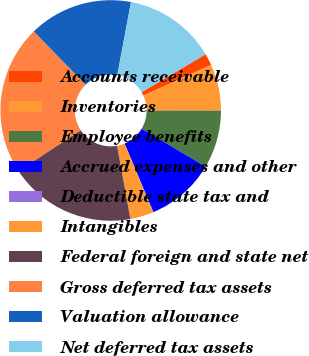Convert chart. <chart><loc_0><loc_0><loc_500><loc_500><pie_chart><fcel>Accounts receivable<fcel>Inventories<fcel>Employee benefits<fcel>Accrued expenses and other<fcel>Deductible state tax and<fcel>Intangibles<fcel>Federal foreign and state net<fcel>Gross deferred tax assets<fcel>Valuation allowance<fcel>Net deferred tax assets<nl><fcel>1.74%<fcel>6.8%<fcel>8.48%<fcel>10.17%<fcel>0.05%<fcel>3.42%<fcel>18.6%<fcel>21.97%<fcel>15.23%<fcel>13.54%<nl></chart> 